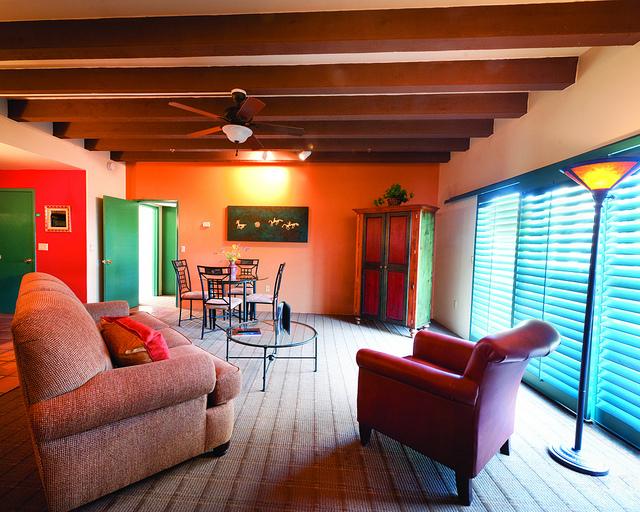Is the light on?
Concise answer only. Yes. What color is the door?
Short answer required. Green. Which light source is dominant, electric or natural?
Write a very short answer. Natural. 